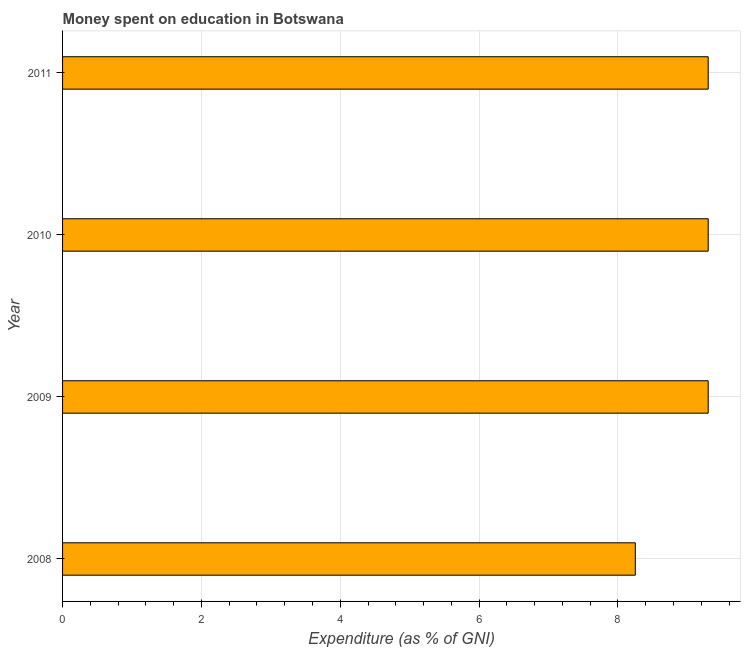Does the graph contain any zero values?
Your response must be concise. No. What is the title of the graph?
Your response must be concise. Money spent on education in Botswana. What is the label or title of the X-axis?
Give a very brief answer. Expenditure (as % of GNI). What is the label or title of the Y-axis?
Ensure brevity in your answer.  Year. What is the expenditure on education in 2008?
Ensure brevity in your answer.  8.25. Across all years, what is the minimum expenditure on education?
Make the answer very short. 8.25. In which year was the expenditure on education maximum?
Ensure brevity in your answer.  2009. What is the sum of the expenditure on education?
Make the answer very short. 36.15. What is the difference between the expenditure on education in 2008 and 2011?
Offer a terse response. -1.05. What is the average expenditure on education per year?
Provide a short and direct response. 9.04. Do a majority of the years between 2009 and 2011 (inclusive) have expenditure on education greater than 2 %?
Make the answer very short. Yes. What is the ratio of the expenditure on education in 2008 to that in 2011?
Ensure brevity in your answer.  0.89. Is the difference between the expenditure on education in 2009 and 2010 greater than the difference between any two years?
Keep it short and to the point. No. What is the difference between the highest and the lowest expenditure on education?
Your response must be concise. 1.05. How many years are there in the graph?
Ensure brevity in your answer.  4. What is the difference between two consecutive major ticks on the X-axis?
Offer a very short reply. 2. Are the values on the major ticks of X-axis written in scientific E-notation?
Your answer should be very brief. No. What is the Expenditure (as % of GNI) in 2008?
Your answer should be very brief. 8.25. What is the Expenditure (as % of GNI) of 2010?
Ensure brevity in your answer.  9.3. What is the difference between the Expenditure (as % of GNI) in 2008 and 2009?
Keep it short and to the point. -1.05. What is the difference between the Expenditure (as % of GNI) in 2008 and 2010?
Keep it short and to the point. -1.05. What is the difference between the Expenditure (as % of GNI) in 2008 and 2011?
Keep it short and to the point. -1.05. What is the difference between the Expenditure (as % of GNI) in 2009 and 2011?
Provide a short and direct response. 0. What is the difference between the Expenditure (as % of GNI) in 2010 and 2011?
Ensure brevity in your answer.  0. What is the ratio of the Expenditure (as % of GNI) in 2008 to that in 2009?
Offer a very short reply. 0.89. What is the ratio of the Expenditure (as % of GNI) in 2008 to that in 2010?
Keep it short and to the point. 0.89. What is the ratio of the Expenditure (as % of GNI) in 2008 to that in 2011?
Provide a short and direct response. 0.89. What is the ratio of the Expenditure (as % of GNI) in 2009 to that in 2010?
Give a very brief answer. 1. What is the ratio of the Expenditure (as % of GNI) in 2009 to that in 2011?
Ensure brevity in your answer.  1. What is the ratio of the Expenditure (as % of GNI) in 2010 to that in 2011?
Offer a very short reply. 1. 